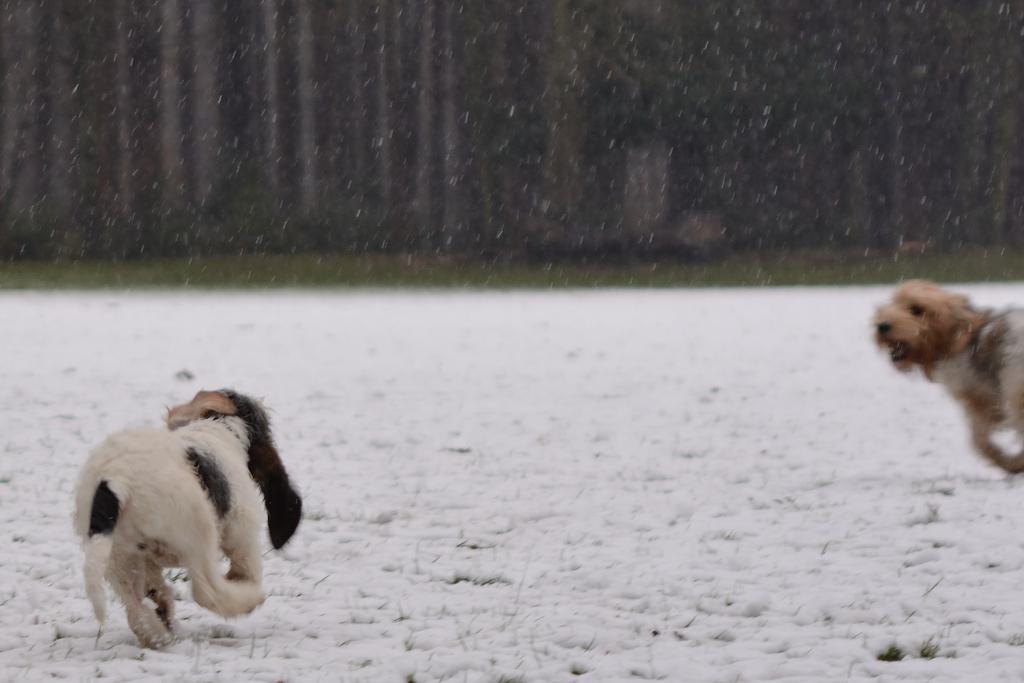In one or two sentences, can you explain what this image depicts? In this picture we can observe two dogs running on the snow. One of the dogs is in white and black color. We can observe snowfall. In the background there are trees. 